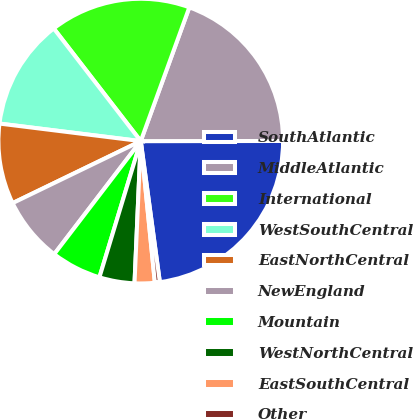<chart> <loc_0><loc_0><loc_500><loc_500><pie_chart><fcel>SouthAtlantic<fcel>MiddleAtlantic<fcel>International<fcel>WestSouthCentral<fcel>EastNorthCentral<fcel>NewEngland<fcel>Mountain<fcel>WestNorthCentral<fcel>EastSouthCentral<fcel>Other<nl><fcel>22.87%<fcel>19.44%<fcel>16.01%<fcel>12.57%<fcel>9.14%<fcel>7.43%<fcel>5.71%<fcel>3.99%<fcel>2.28%<fcel>0.56%<nl></chart> 